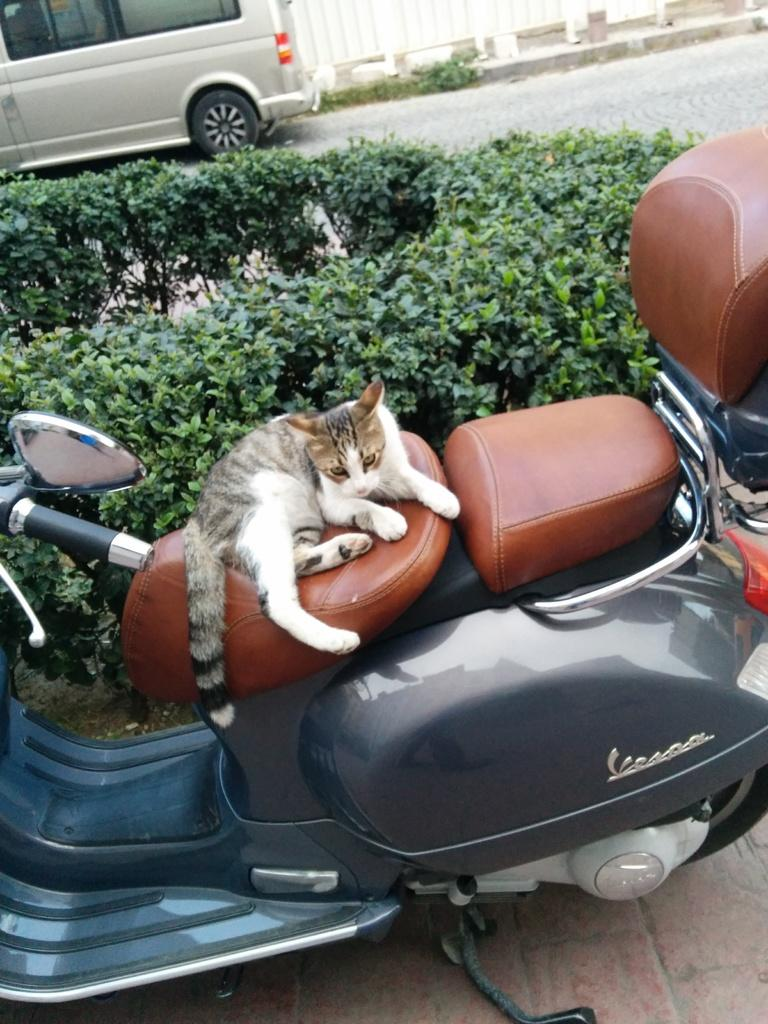What animal is in the image? There is a cat in the image. What is the cat doing in the image? The cat is sitting on a scooter. What can be seen in the background of the image? There is a vehicle and trees visible in the background of the image. What type of body comfort does the cat provide in the image? The image does not show the cat providing any body comfort; it is simply sitting on a scooter. Can you see a toad in the image? There is no toad present in the image. 